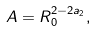<formula> <loc_0><loc_0><loc_500><loc_500>A = R _ { 0 } ^ { 2 - 2 a _ { 2 } } ,</formula> 